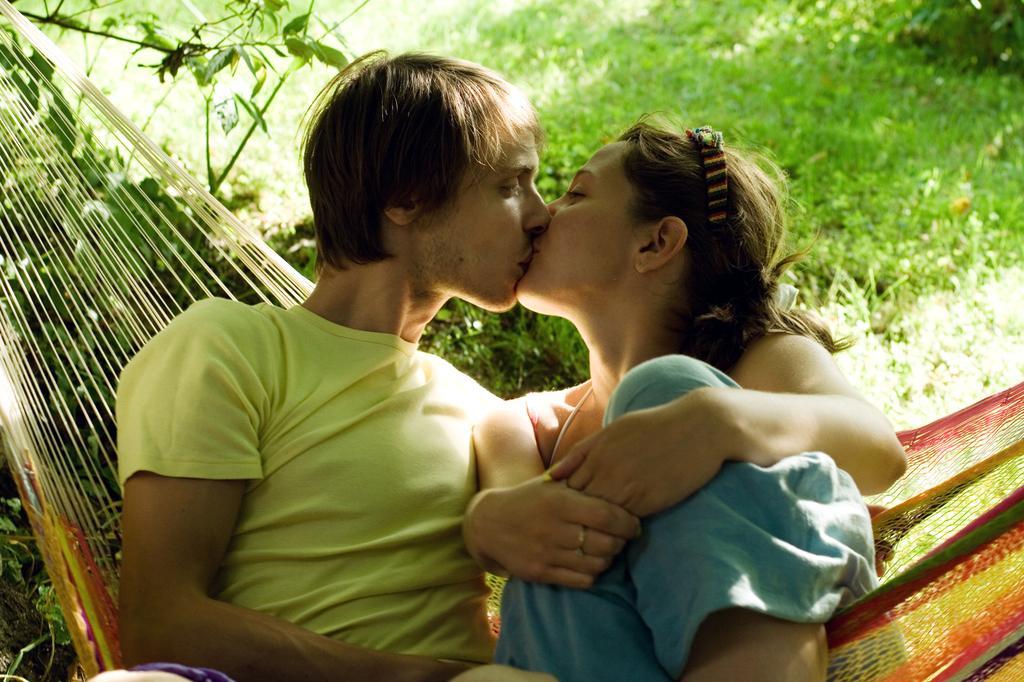Describe this image in one or two sentences. On the left side, there is a person in a yellow color t-shirt, sitting and lip kissing with a woman who is sitting on a net. In the background, there are plants and grass on the ground. 